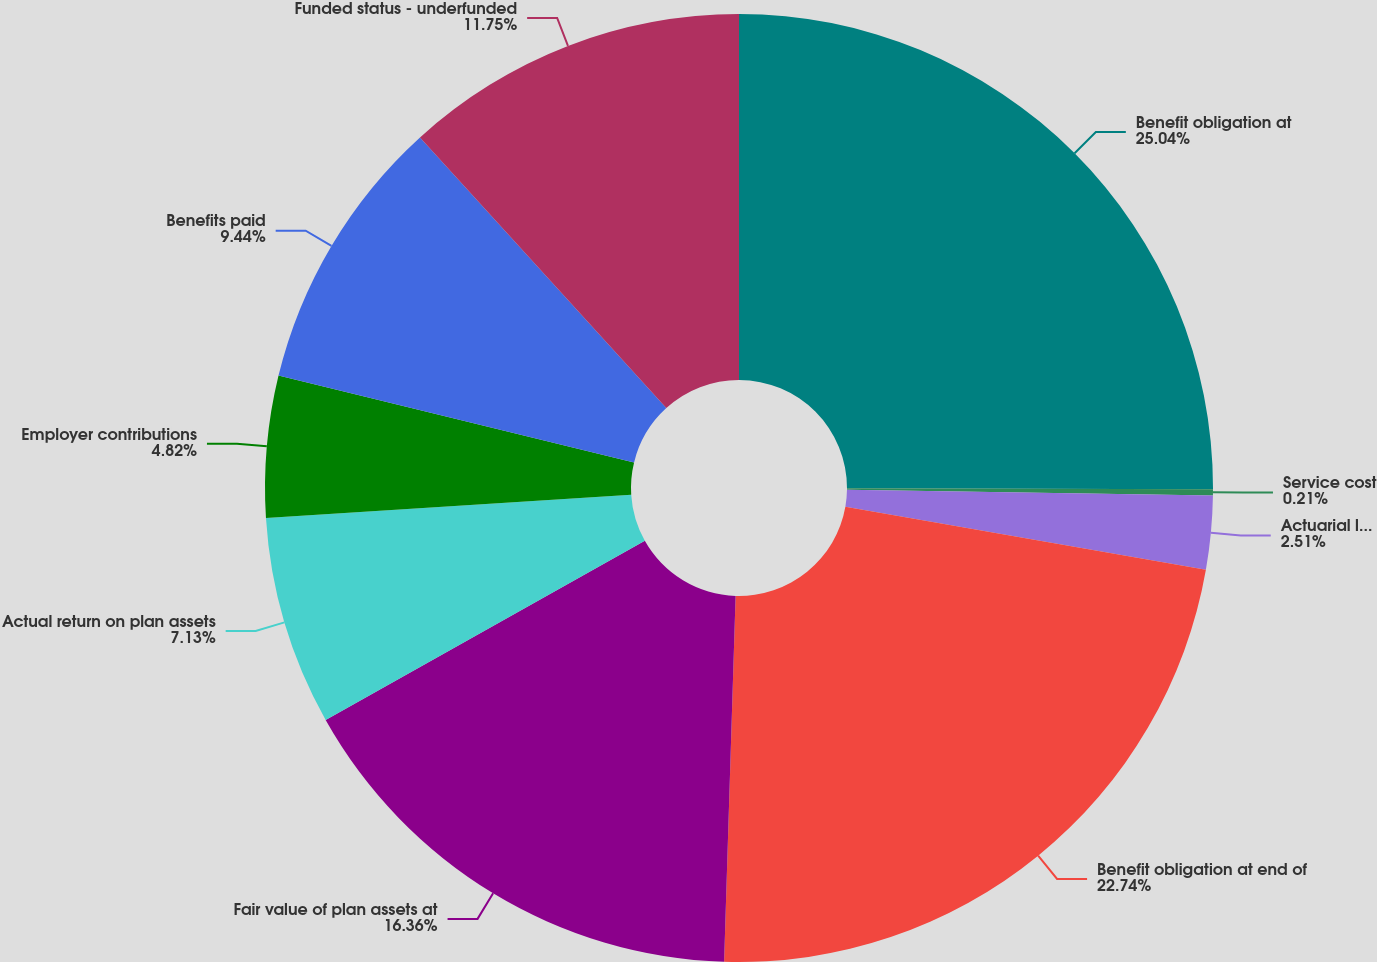Convert chart to OTSL. <chart><loc_0><loc_0><loc_500><loc_500><pie_chart><fcel>Benefit obligation at<fcel>Service cost<fcel>Actuarial loss (gain)<fcel>Benefit obligation at end of<fcel>Fair value of plan assets at<fcel>Actual return on plan assets<fcel>Employer contributions<fcel>Benefits paid<fcel>Funded status - underfunded<nl><fcel>25.04%<fcel>0.21%<fcel>2.51%<fcel>22.74%<fcel>16.36%<fcel>7.13%<fcel>4.82%<fcel>9.44%<fcel>11.75%<nl></chart> 